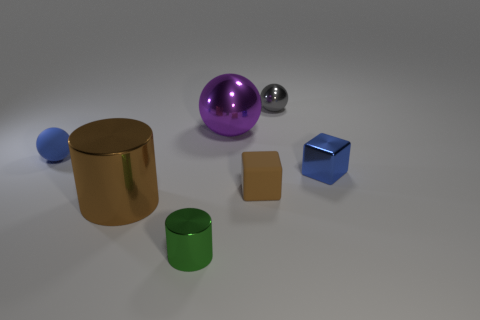Subtract all tiny blue spheres. How many spheres are left? 2 Subtract all blue balls. How many balls are left? 2 Subtract all balls. How many objects are left? 4 Add 3 metallic balls. How many objects exist? 10 Subtract all blue balls. How many blue cubes are left? 1 Subtract all brown matte things. Subtract all brown matte blocks. How many objects are left? 5 Add 4 big metal cylinders. How many big metal cylinders are left? 5 Add 2 big purple metallic things. How many big purple metallic things exist? 3 Subtract 0 cyan blocks. How many objects are left? 7 Subtract 1 cylinders. How many cylinders are left? 1 